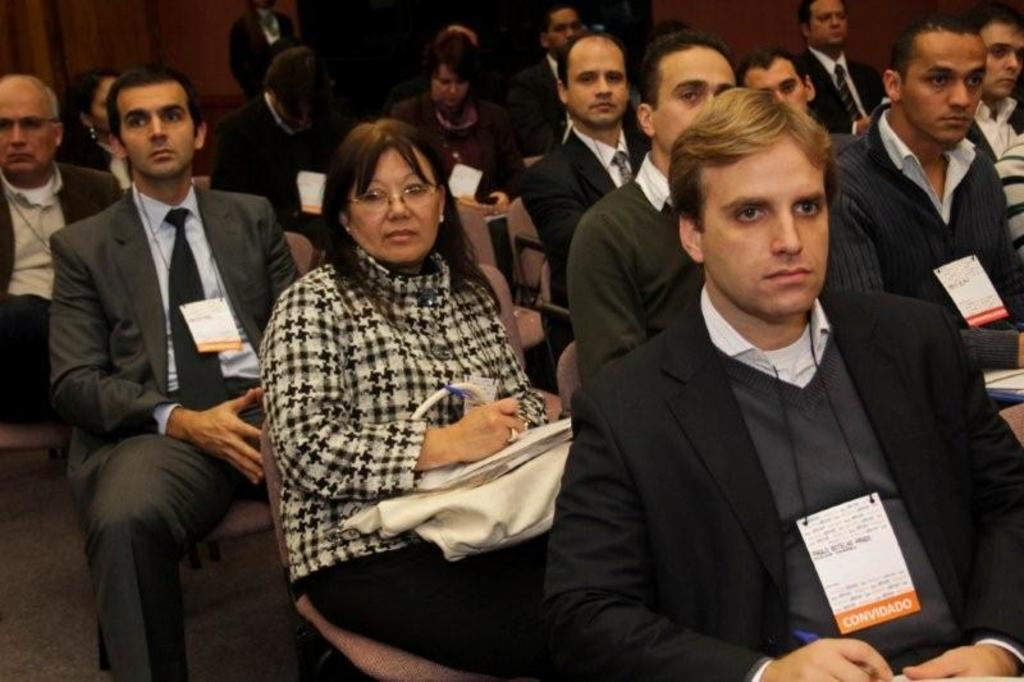What is the main subject of the image? The main subject of the image is a group of people. What are the people doing in the image? The people are sitting on a chair in the image. Can you describe any objects that the people are holding? Some people are holding objects in their hands in the image. What type of rock can be seen in the image? There is no rock present in the image; it features a group of people sitting on a chair. What is the body doing in the image? There is no body present in the image; it features a group of people sitting on a chair. 